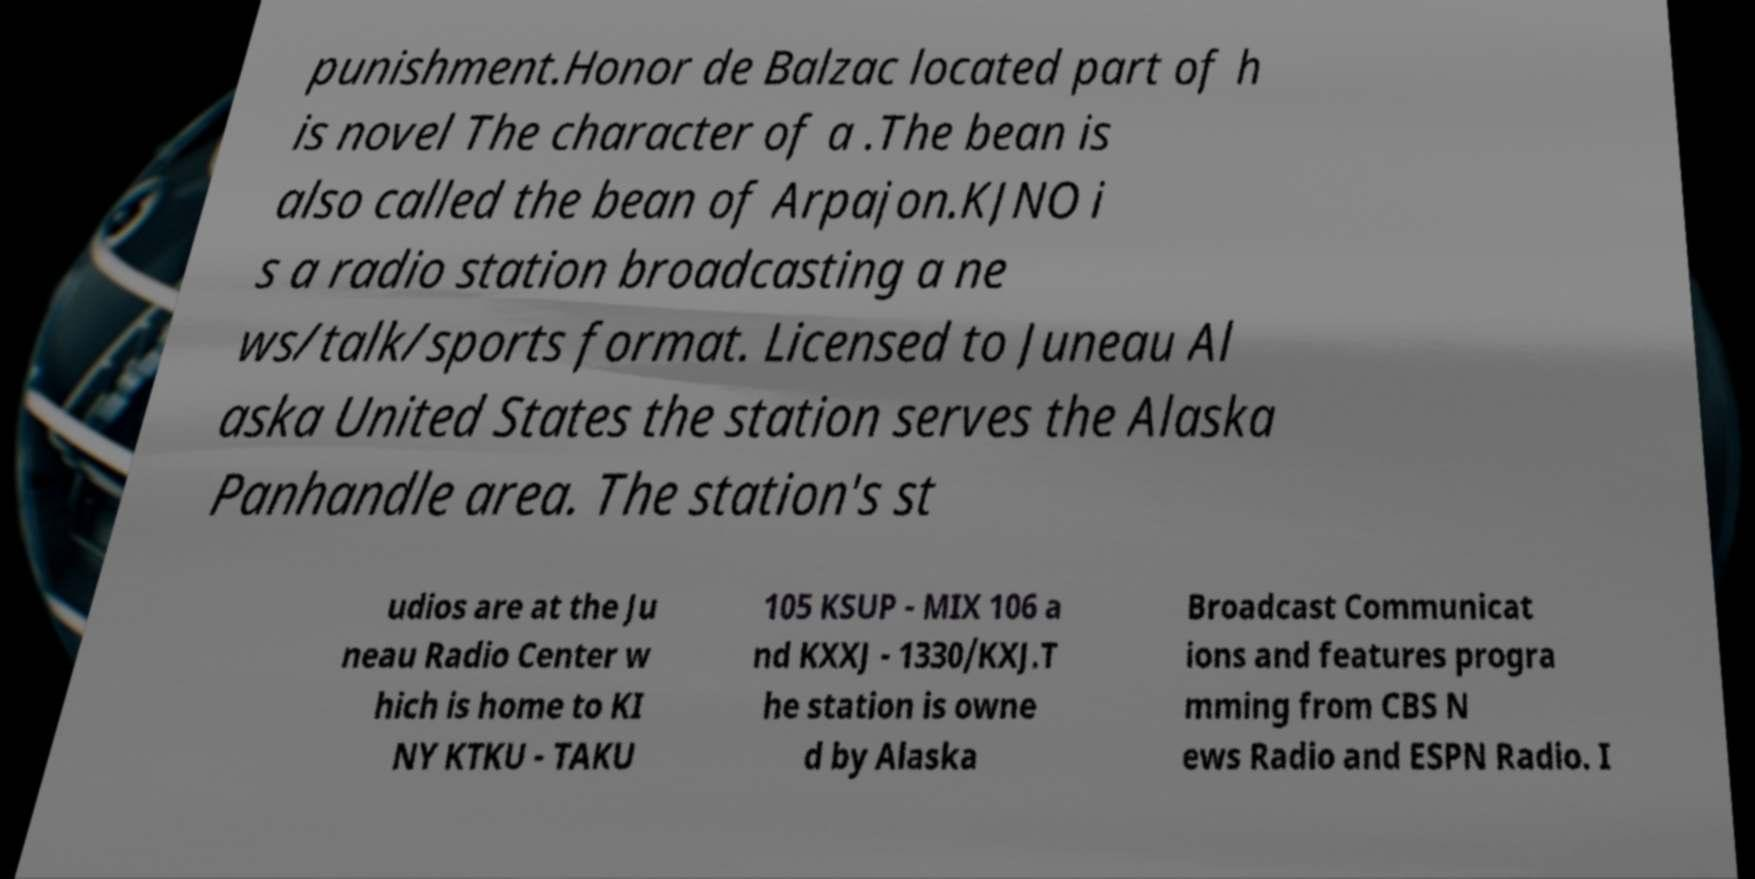Can you accurately transcribe the text from the provided image for me? punishment.Honor de Balzac located part of h is novel The character of a .The bean is also called the bean of Arpajon.KJNO i s a radio station broadcasting a ne ws/talk/sports format. Licensed to Juneau Al aska United States the station serves the Alaska Panhandle area. The station's st udios are at the Ju neau Radio Center w hich is home to KI NY KTKU - TAKU 105 KSUP - MIX 106 a nd KXXJ - 1330/KXJ.T he station is owne d by Alaska Broadcast Communicat ions and features progra mming from CBS N ews Radio and ESPN Radio. I 